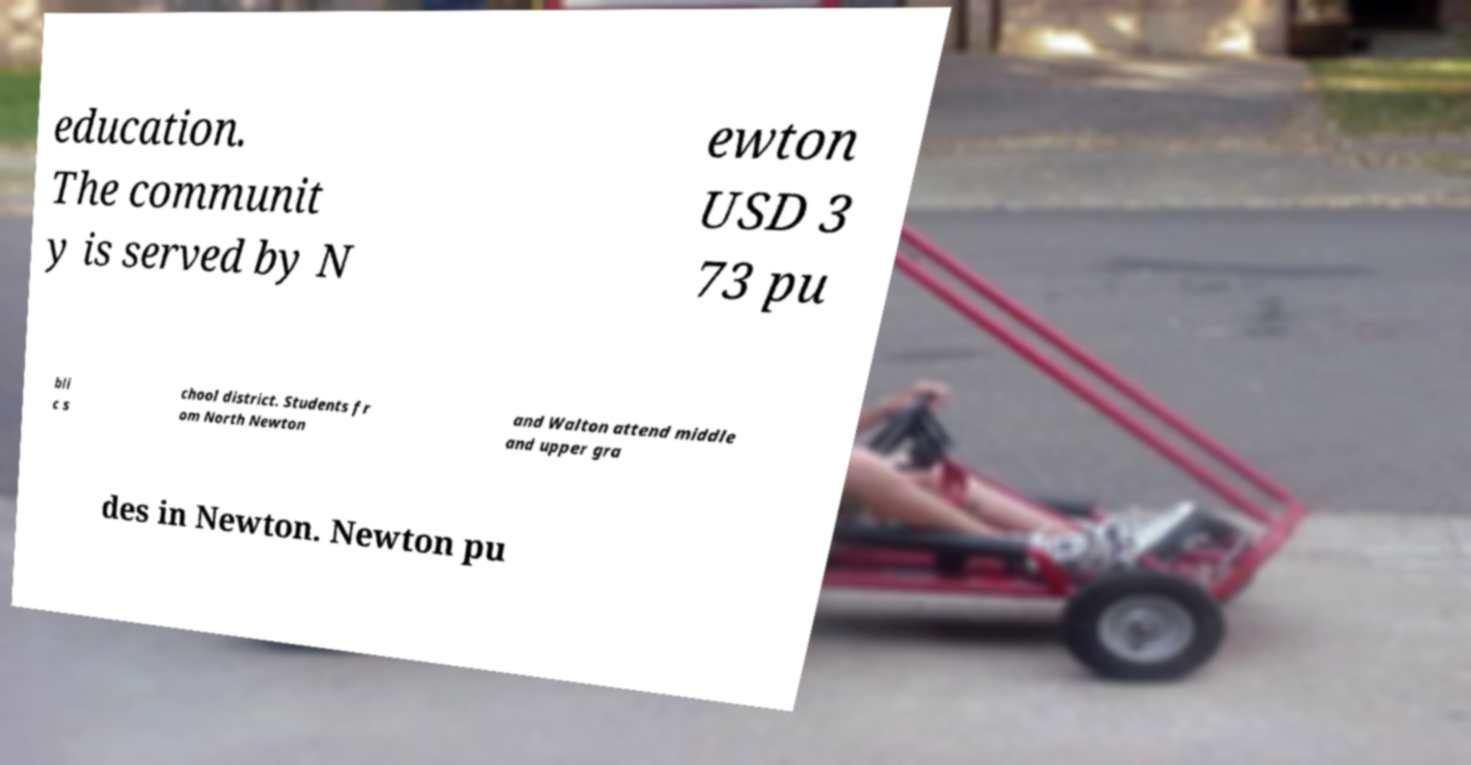Please identify and transcribe the text found in this image. education. The communit y is served by N ewton USD 3 73 pu bli c s chool district. Students fr om North Newton and Walton attend middle and upper gra des in Newton. Newton pu 